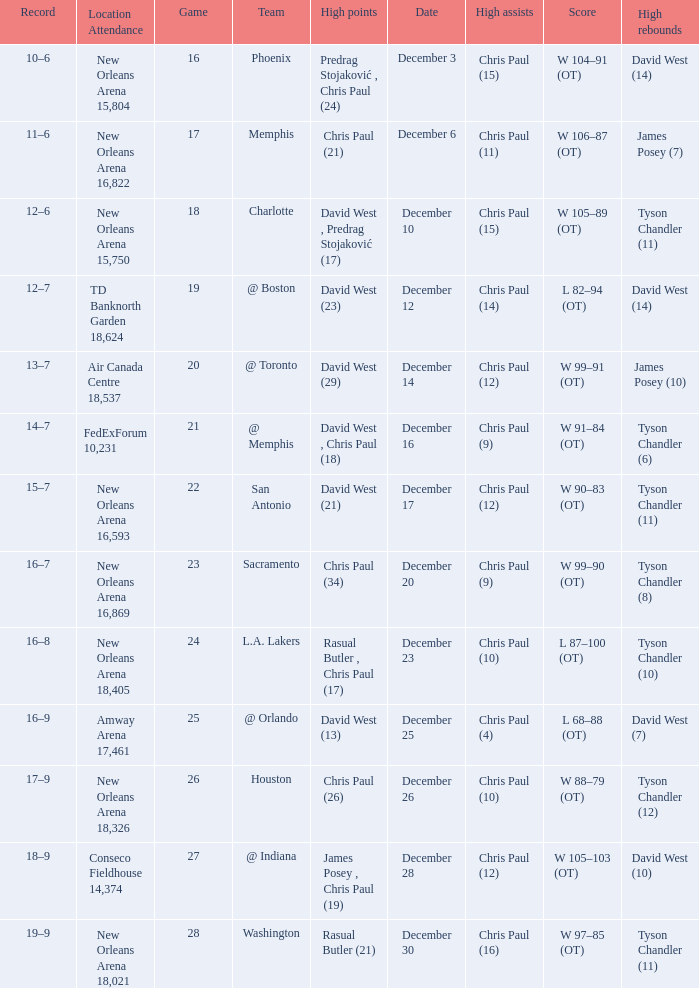What is the average Game, when Date is "December 23"? 24.0. 